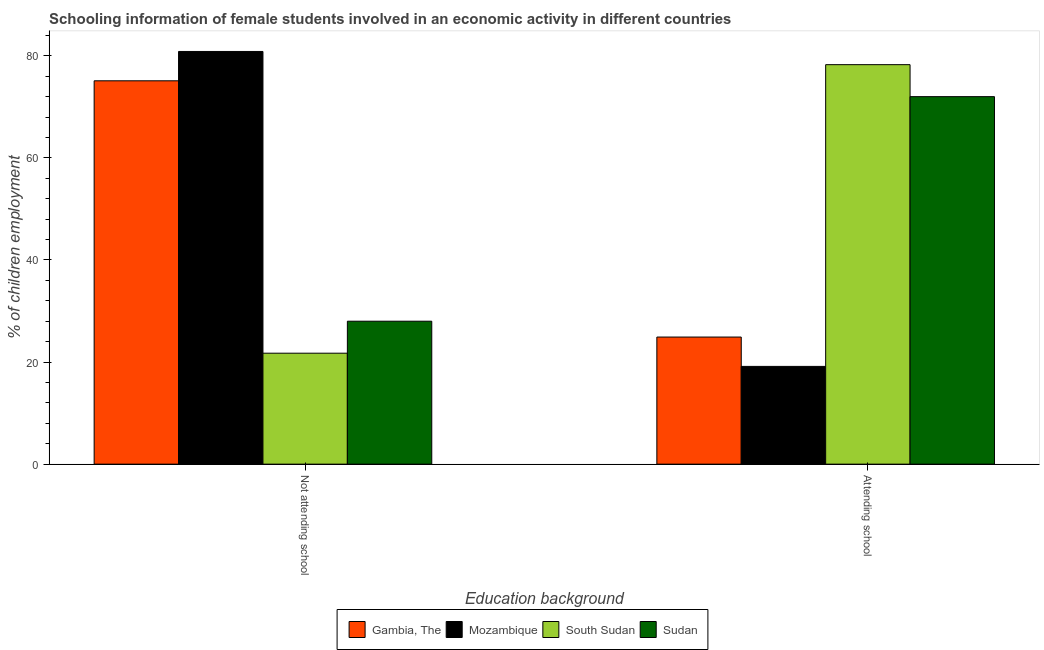How many different coloured bars are there?
Ensure brevity in your answer.  4. Are the number of bars per tick equal to the number of legend labels?
Your answer should be compact. Yes. How many bars are there on the 2nd tick from the right?
Provide a short and direct response. 4. What is the label of the 2nd group of bars from the left?
Your answer should be compact. Attending school. What is the percentage of employed females who are not attending school in Gambia, The?
Make the answer very short. 75.1. Across all countries, what is the maximum percentage of employed females who are not attending school?
Keep it short and to the point. 80.85. Across all countries, what is the minimum percentage of employed females who are attending school?
Provide a short and direct response. 19.15. In which country was the percentage of employed females who are attending school maximum?
Your response must be concise. South Sudan. In which country was the percentage of employed females who are not attending school minimum?
Keep it short and to the point. South Sudan. What is the total percentage of employed females who are not attending school in the graph?
Offer a terse response. 205.69. What is the difference between the percentage of employed females who are not attending school in Sudan and that in Mozambique?
Make the answer very short. -52.85. What is the difference between the percentage of employed females who are not attending school in Gambia, The and the percentage of employed females who are attending school in South Sudan?
Give a very brief answer. -3.16. What is the average percentage of employed females who are not attending school per country?
Your answer should be compact. 51.42. What is the difference between the percentage of employed females who are attending school and percentage of employed females who are not attending school in South Sudan?
Ensure brevity in your answer.  56.53. What is the ratio of the percentage of employed females who are not attending school in Sudan to that in Gambia, The?
Ensure brevity in your answer.  0.37. What does the 2nd bar from the left in Not attending school represents?
Make the answer very short. Mozambique. What does the 3rd bar from the right in Not attending school represents?
Ensure brevity in your answer.  Mozambique. How many bars are there?
Your answer should be very brief. 8. How many countries are there in the graph?
Offer a terse response. 4. Are the values on the major ticks of Y-axis written in scientific E-notation?
Provide a succinct answer. No. What is the title of the graph?
Keep it short and to the point. Schooling information of female students involved in an economic activity in different countries. What is the label or title of the X-axis?
Your response must be concise. Education background. What is the label or title of the Y-axis?
Your response must be concise. % of children employment. What is the % of children employment in Gambia, The in Not attending school?
Make the answer very short. 75.1. What is the % of children employment of Mozambique in Not attending school?
Your response must be concise. 80.85. What is the % of children employment of South Sudan in Not attending school?
Your response must be concise. 21.74. What is the % of children employment in Sudan in Not attending school?
Make the answer very short. 28. What is the % of children employment of Gambia, The in Attending school?
Give a very brief answer. 24.9. What is the % of children employment of Mozambique in Attending school?
Your answer should be compact. 19.15. What is the % of children employment in South Sudan in Attending school?
Your answer should be very brief. 78.26. What is the % of children employment of Sudan in Attending school?
Provide a short and direct response. 72. Across all Education background, what is the maximum % of children employment of Gambia, The?
Give a very brief answer. 75.1. Across all Education background, what is the maximum % of children employment of Mozambique?
Give a very brief answer. 80.85. Across all Education background, what is the maximum % of children employment in South Sudan?
Give a very brief answer. 78.26. Across all Education background, what is the maximum % of children employment in Sudan?
Give a very brief answer. 72. Across all Education background, what is the minimum % of children employment in Gambia, The?
Offer a very short reply. 24.9. Across all Education background, what is the minimum % of children employment of Mozambique?
Your response must be concise. 19.15. Across all Education background, what is the minimum % of children employment in South Sudan?
Provide a succinct answer. 21.74. Across all Education background, what is the minimum % of children employment in Sudan?
Your answer should be very brief. 28. What is the total % of children employment in Gambia, The in the graph?
Give a very brief answer. 100. What is the total % of children employment of Mozambique in the graph?
Provide a succinct answer. 100. What is the total % of children employment in Sudan in the graph?
Offer a very short reply. 100. What is the difference between the % of children employment in Gambia, The in Not attending school and that in Attending school?
Offer a terse response. 50.2. What is the difference between the % of children employment of Mozambique in Not attending school and that in Attending school?
Your response must be concise. 61.7. What is the difference between the % of children employment in South Sudan in Not attending school and that in Attending school?
Give a very brief answer. -56.53. What is the difference between the % of children employment in Sudan in Not attending school and that in Attending school?
Ensure brevity in your answer.  -43.99. What is the difference between the % of children employment in Gambia, The in Not attending school and the % of children employment in Mozambique in Attending school?
Make the answer very short. 55.95. What is the difference between the % of children employment of Gambia, The in Not attending school and the % of children employment of South Sudan in Attending school?
Give a very brief answer. -3.16. What is the difference between the % of children employment in Gambia, The in Not attending school and the % of children employment in Sudan in Attending school?
Give a very brief answer. 3.1. What is the difference between the % of children employment in Mozambique in Not attending school and the % of children employment in South Sudan in Attending school?
Provide a short and direct response. 2.59. What is the difference between the % of children employment in Mozambique in Not attending school and the % of children employment in Sudan in Attending school?
Provide a succinct answer. 8.85. What is the difference between the % of children employment in South Sudan in Not attending school and the % of children employment in Sudan in Attending school?
Your answer should be compact. -50.26. What is the average % of children employment of South Sudan per Education background?
Provide a succinct answer. 50. What is the average % of children employment in Sudan per Education background?
Provide a short and direct response. 50. What is the difference between the % of children employment of Gambia, The and % of children employment of Mozambique in Not attending school?
Your answer should be very brief. -5.75. What is the difference between the % of children employment in Gambia, The and % of children employment in South Sudan in Not attending school?
Make the answer very short. 53.36. What is the difference between the % of children employment in Gambia, The and % of children employment in Sudan in Not attending school?
Offer a terse response. 47.1. What is the difference between the % of children employment of Mozambique and % of children employment of South Sudan in Not attending school?
Keep it short and to the point. 59.11. What is the difference between the % of children employment in Mozambique and % of children employment in Sudan in Not attending school?
Provide a succinct answer. 52.85. What is the difference between the % of children employment of South Sudan and % of children employment of Sudan in Not attending school?
Your response must be concise. -6.27. What is the difference between the % of children employment of Gambia, The and % of children employment of Mozambique in Attending school?
Your response must be concise. 5.75. What is the difference between the % of children employment in Gambia, The and % of children employment in South Sudan in Attending school?
Your response must be concise. -53.36. What is the difference between the % of children employment of Gambia, The and % of children employment of Sudan in Attending school?
Offer a terse response. -47.1. What is the difference between the % of children employment in Mozambique and % of children employment in South Sudan in Attending school?
Ensure brevity in your answer.  -59.11. What is the difference between the % of children employment of Mozambique and % of children employment of Sudan in Attending school?
Offer a terse response. -52.85. What is the difference between the % of children employment in South Sudan and % of children employment in Sudan in Attending school?
Ensure brevity in your answer.  6.27. What is the ratio of the % of children employment of Gambia, The in Not attending school to that in Attending school?
Give a very brief answer. 3.02. What is the ratio of the % of children employment in Mozambique in Not attending school to that in Attending school?
Your answer should be very brief. 4.22. What is the ratio of the % of children employment of South Sudan in Not attending school to that in Attending school?
Your response must be concise. 0.28. What is the ratio of the % of children employment in Sudan in Not attending school to that in Attending school?
Ensure brevity in your answer.  0.39. What is the difference between the highest and the second highest % of children employment of Gambia, The?
Your answer should be very brief. 50.2. What is the difference between the highest and the second highest % of children employment in Mozambique?
Ensure brevity in your answer.  61.7. What is the difference between the highest and the second highest % of children employment in South Sudan?
Your answer should be very brief. 56.53. What is the difference between the highest and the second highest % of children employment in Sudan?
Your answer should be compact. 43.99. What is the difference between the highest and the lowest % of children employment in Gambia, The?
Provide a short and direct response. 50.2. What is the difference between the highest and the lowest % of children employment of Mozambique?
Provide a short and direct response. 61.7. What is the difference between the highest and the lowest % of children employment in South Sudan?
Offer a very short reply. 56.53. What is the difference between the highest and the lowest % of children employment of Sudan?
Give a very brief answer. 43.99. 